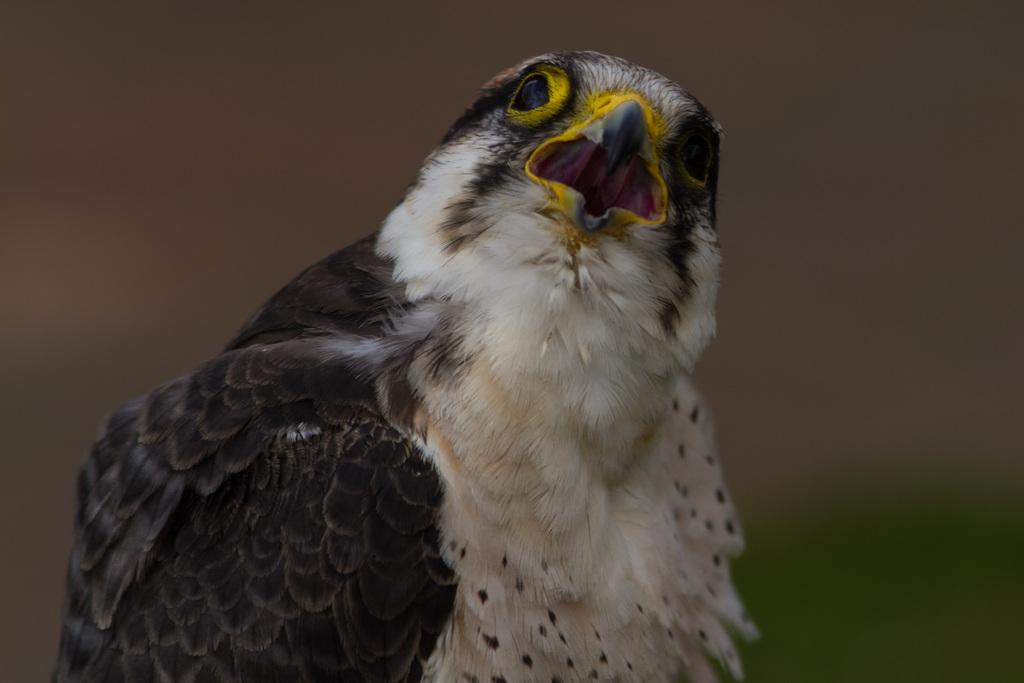What type of bird is in the image? There is a hawk bird in the image. What are the color features of the hawk bird? The hawk bird has black and white features. What distinguishing markings does the hawk bird have? The hawk bird has yellow borders around its eyes and nose. How would you describe the background of the image? The background of the image is blurred. What type of shop can be seen in the background of the image? There is no shop visible in the background of the image; the background is blurred. Can you describe the garden where the hawk bird is perched? There is no garden present in the image; it only features the hawk bird and a blurred background. 